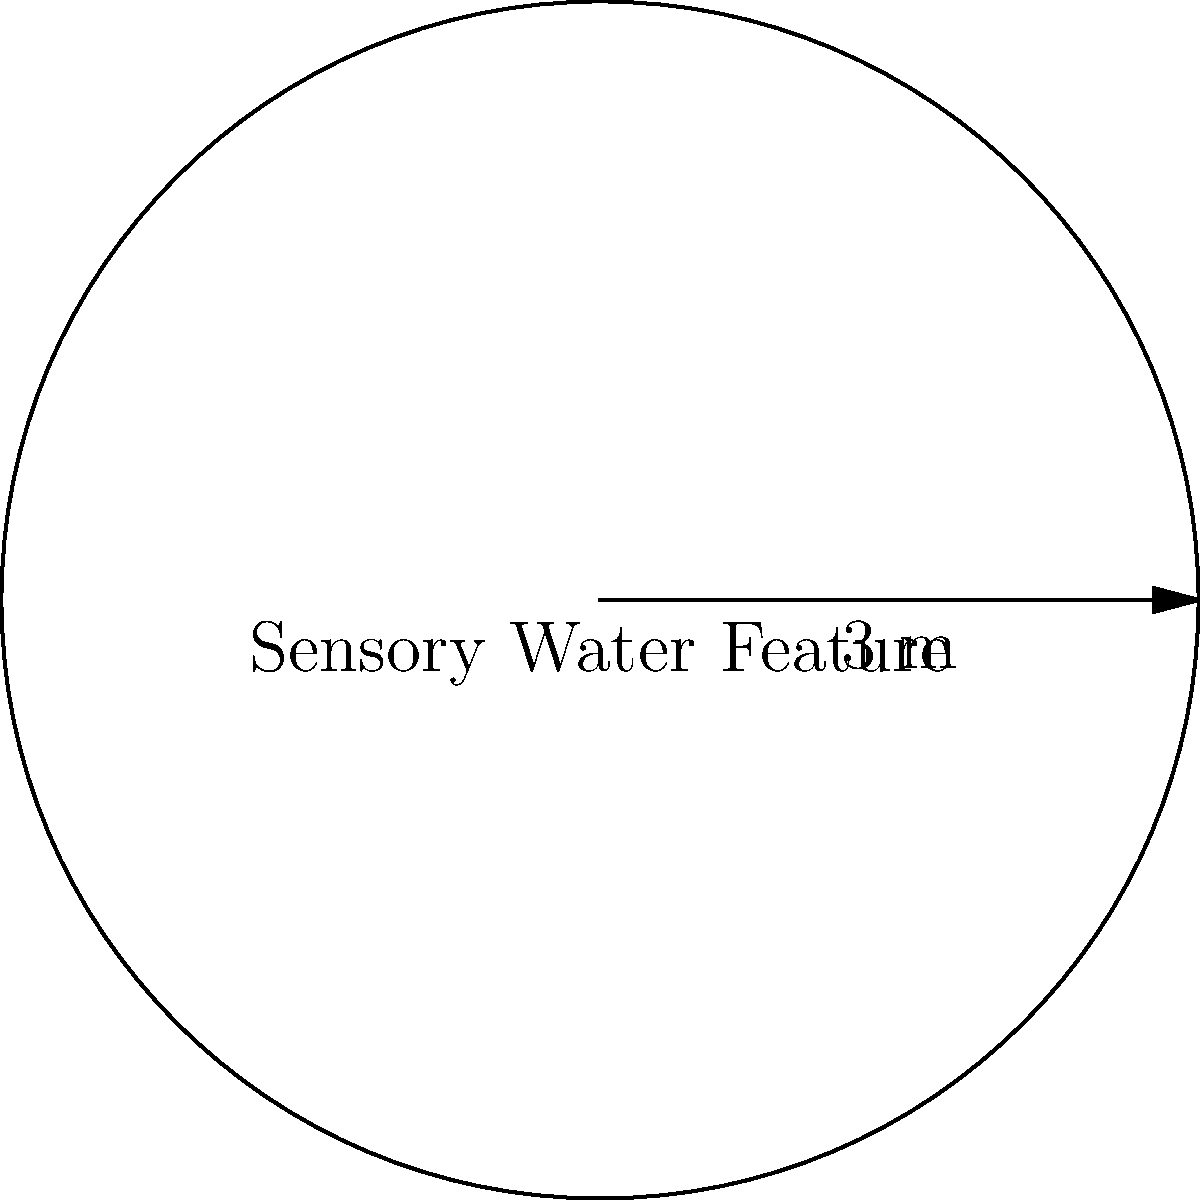You want to create a circular sensory water feature in your garden for your child with special needs. If the radius of the water feature is 3 meters, what is the area of the water feature? Round your answer to the nearest square meter. To find the area of a circular water feature, we need to use the formula for the area of a circle:

$$A = \pi r^2$$

Where:
$A$ = Area of the circle
$\pi$ (pi) ≈ 3.14159
$r$ = Radius of the circle

Given:
Radius $(r) = 3$ meters

Let's calculate the area:

$$\begin{align}
A &= \pi r^2 \\
&= \pi \cdot (3\text{ m})^2 \\
&= \pi \cdot 9\text{ m}^2 \\
&≈ 3.14159 \cdot 9\text{ m}^2 \\
&≈ 28.27431\text{ m}^2
\end{align}$$

Rounding to the nearest square meter:

$$A ≈ 28\text{ m}^2$$
Answer: 28 m² 